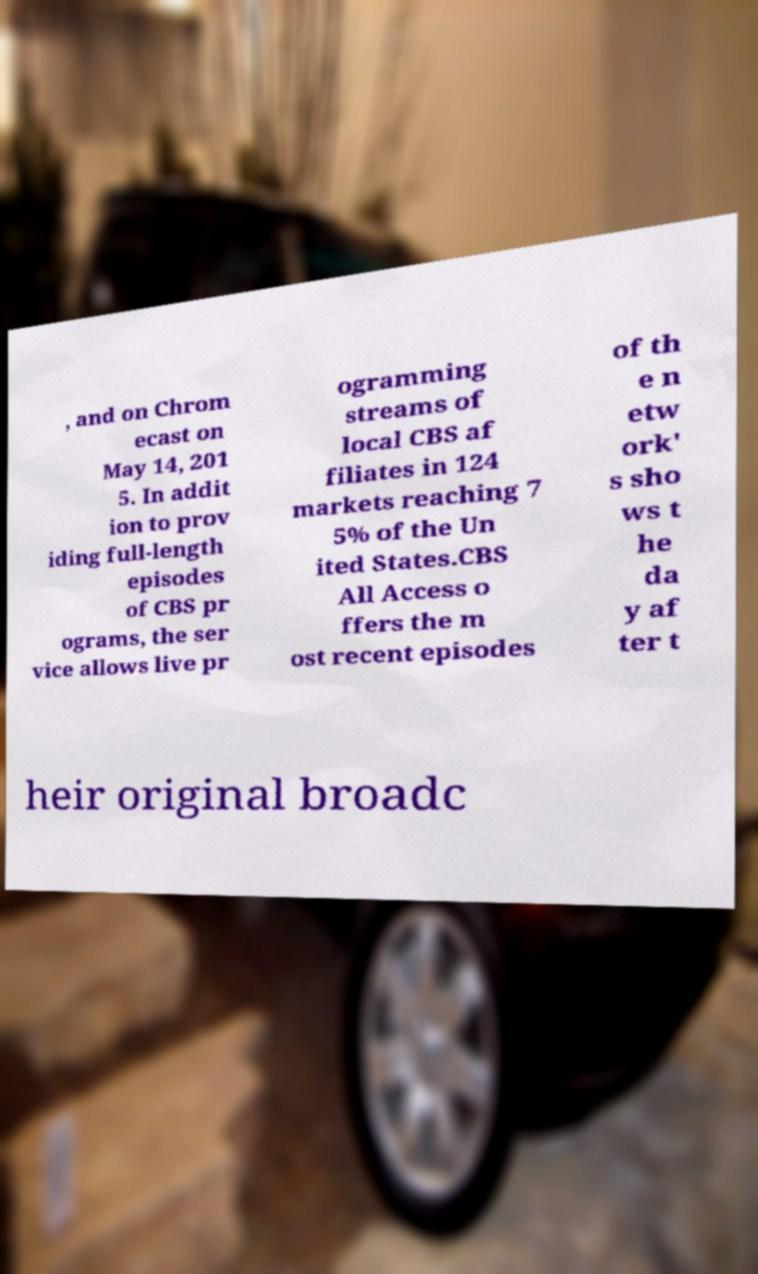Could you assist in decoding the text presented in this image and type it out clearly? , and on Chrom ecast on May 14, 201 5. In addit ion to prov iding full-length episodes of CBS pr ograms, the ser vice allows live pr ogramming streams of local CBS af filiates in 124 markets reaching 7 5% of the Un ited States.CBS All Access o ffers the m ost recent episodes of th e n etw ork' s sho ws t he da y af ter t heir original broadc 